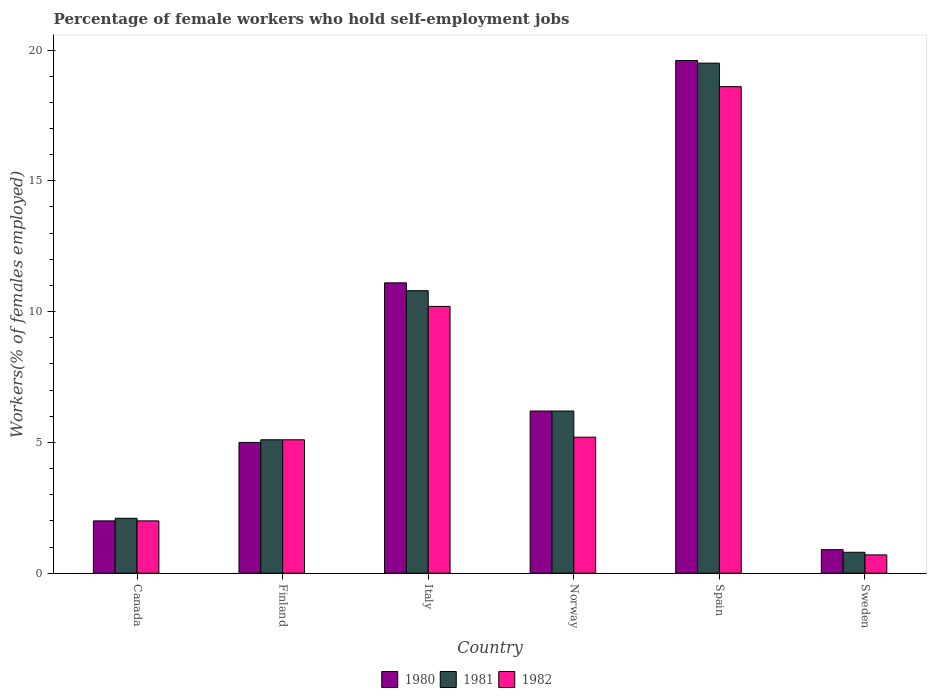How many groups of bars are there?
Your response must be concise. 6. Are the number of bars per tick equal to the number of legend labels?
Your answer should be very brief. Yes. Are the number of bars on each tick of the X-axis equal?
Your response must be concise. Yes. How many bars are there on the 6th tick from the right?
Your answer should be compact. 3. In how many cases, is the number of bars for a given country not equal to the number of legend labels?
Offer a very short reply. 0. What is the percentage of self-employed female workers in 1982 in Finland?
Keep it short and to the point. 5.1. Across all countries, what is the maximum percentage of self-employed female workers in 1980?
Provide a short and direct response. 19.6. Across all countries, what is the minimum percentage of self-employed female workers in 1981?
Provide a short and direct response. 0.8. In which country was the percentage of self-employed female workers in 1982 maximum?
Your answer should be very brief. Spain. In which country was the percentage of self-employed female workers in 1981 minimum?
Provide a short and direct response. Sweden. What is the total percentage of self-employed female workers in 1980 in the graph?
Offer a very short reply. 44.8. What is the difference between the percentage of self-employed female workers in 1981 in Finland and that in Spain?
Your response must be concise. -14.4. What is the difference between the percentage of self-employed female workers in 1980 in Canada and the percentage of self-employed female workers in 1981 in Spain?
Offer a very short reply. -17.5. What is the average percentage of self-employed female workers in 1982 per country?
Give a very brief answer. 6.97. What is the difference between the percentage of self-employed female workers of/in 1981 and percentage of self-employed female workers of/in 1980 in Italy?
Keep it short and to the point. -0.3. What is the ratio of the percentage of self-employed female workers in 1980 in Spain to that in Sweden?
Your answer should be very brief. 21.78. What is the difference between the highest and the second highest percentage of self-employed female workers in 1980?
Keep it short and to the point. -8.5. What is the difference between the highest and the lowest percentage of self-employed female workers in 1980?
Your response must be concise. 18.7. In how many countries, is the percentage of self-employed female workers in 1980 greater than the average percentage of self-employed female workers in 1980 taken over all countries?
Give a very brief answer. 2. Is the sum of the percentage of self-employed female workers in 1980 in Italy and Sweden greater than the maximum percentage of self-employed female workers in 1981 across all countries?
Provide a succinct answer. No. Is it the case that in every country, the sum of the percentage of self-employed female workers in 1981 and percentage of self-employed female workers in 1982 is greater than the percentage of self-employed female workers in 1980?
Ensure brevity in your answer.  Yes. How many bars are there?
Your response must be concise. 18. Are all the bars in the graph horizontal?
Your answer should be very brief. No. How many countries are there in the graph?
Provide a short and direct response. 6. Does the graph contain any zero values?
Your response must be concise. No. How many legend labels are there?
Provide a short and direct response. 3. How are the legend labels stacked?
Make the answer very short. Horizontal. What is the title of the graph?
Make the answer very short. Percentage of female workers who hold self-employment jobs. What is the label or title of the X-axis?
Provide a short and direct response. Country. What is the label or title of the Y-axis?
Provide a short and direct response. Workers(% of females employed). What is the Workers(% of females employed) in 1980 in Canada?
Offer a very short reply. 2. What is the Workers(% of females employed) of 1981 in Canada?
Ensure brevity in your answer.  2.1. What is the Workers(% of females employed) in 1982 in Canada?
Make the answer very short. 2. What is the Workers(% of females employed) of 1980 in Finland?
Your response must be concise. 5. What is the Workers(% of females employed) in 1981 in Finland?
Make the answer very short. 5.1. What is the Workers(% of females employed) in 1982 in Finland?
Offer a very short reply. 5.1. What is the Workers(% of females employed) of 1980 in Italy?
Give a very brief answer. 11.1. What is the Workers(% of females employed) of 1981 in Italy?
Provide a succinct answer. 10.8. What is the Workers(% of females employed) in 1982 in Italy?
Your response must be concise. 10.2. What is the Workers(% of females employed) of 1980 in Norway?
Make the answer very short. 6.2. What is the Workers(% of females employed) in 1981 in Norway?
Your answer should be compact. 6.2. What is the Workers(% of females employed) of 1982 in Norway?
Provide a short and direct response. 5.2. What is the Workers(% of females employed) in 1980 in Spain?
Offer a very short reply. 19.6. What is the Workers(% of females employed) in 1981 in Spain?
Ensure brevity in your answer.  19.5. What is the Workers(% of females employed) in 1982 in Spain?
Provide a short and direct response. 18.6. What is the Workers(% of females employed) of 1980 in Sweden?
Offer a very short reply. 0.9. What is the Workers(% of females employed) in 1981 in Sweden?
Give a very brief answer. 0.8. What is the Workers(% of females employed) of 1982 in Sweden?
Provide a short and direct response. 0.7. Across all countries, what is the maximum Workers(% of females employed) in 1980?
Your answer should be compact. 19.6. Across all countries, what is the maximum Workers(% of females employed) of 1981?
Your answer should be compact. 19.5. Across all countries, what is the maximum Workers(% of females employed) of 1982?
Offer a very short reply. 18.6. Across all countries, what is the minimum Workers(% of females employed) of 1980?
Your answer should be compact. 0.9. Across all countries, what is the minimum Workers(% of females employed) of 1981?
Your response must be concise. 0.8. Across all countries, what is the minimum Workers(% of females employed) in 1982?
Make the answer very short. 0.7. What is the total Workers(% of females employed) of 1980 in the graph?
Make the answer very short. 44.8. What is the total Workers(% of females employed) of 1981 in the graph?
Give a very brief answer. 44.5. What is the total Workers(% of females employed) in 1982 in the graph?
Ensure brevity in your answer.  41.8. What is the difference between the Workers(% of females employed) of 1980 in Canada and that in Finland?
Provide a short and direct response. -3. What is the difference between the Workers(% of females employed) in 1980 in Canada and that in Italy?
Your answer should be very brief. -9.1. What is the difference between the Workers(% of females employed) of 1981 in Canada and that in Italy?
Offer a very short reply. -8.7. What is the difference between the Workers(% of females employed) of 1980 in Canada and that in Norway?
Offer a very short reply. -4.2. What is the difference between the Workers(% of females employed) in 1982 in Canada and that in Norway?
Offer a very short reply. -3.2. What is the difference between the Workers(% of females employed) in 1980 in Canada and that in Spain?
Offer a very short reply. -17.6. What is the difference between the Workers(% of females employed) of 1981 in Canada and that in Spain?
Your response must be concise. -17.4. What is the difference between the Workers(% of females employed) in 1982 in Canada and that in Spain?
Your response must be concise. -16.6. What is the difference between the Workers(% of females employed) of 1980 in Canada and that in Sweden?
Make the answer very short. 1.1. What is the difference between the Workers(% of females employed) of 1981 in Canada and that in Sweden?
Provide a short and direct response. 1.3. What is the difference between the Workers(% of females employed) in 1982 in Canada and that in Sweden?
Your answer should be very brief. 1.3. What is the difference between the Workers(% of females employed) in 1980 in Finland and that in Italy?
Keep it short and to the point. -6.1. What is the difference between the Workers(% of females employed) of 1981 in Finland and that in Italy?
Offer a terse response. -5.7. What is the difference between the Workers(% of females employed) in 1982 in Finland and that in Italy?
Keep it short and to the point. -5.1. What is the difference between the Workers(% of females employed) in 1980 in Finland and that in Spain?
Keep it short and to the point. -14.6. What is the difference between the Workers(% of females employed) in 1981 in Finland and that in Spain?
Give a very brief answer. -14.4. What is the difference between the Workers(% of females employed) in 1982 in Finland and that in Spain?
Keep it short and to the point. -13.5. What is the difference between the Workers(% of females employed) in 1980 in Finland and that in Sweden?
Offer a very short reply. 4.1. What is the difference between the Workers(% of females employed) of 1981 in Finland and that in Sweden?
Your answer should be compact. 4.3. What is the difference between the Workers(% of females employed) in 1980 in Italy and that in Spain?
Provide a short and direct response. -8.5. What is the difference between the Workers(% of females employed) in 1981 in Italy and that in Spain?
Offer a terse response. -8.7. What is the difference between the Workers(% of females employed) of 1982 in Italy and that in Spain?
Ensure brevity in your answer.  -8.4. What is the difference between the Workers(% of females employed) of 1980 in Italy and that in Sweden?
Offer a terse response. 10.2. What is the difference between the Workers(% of females employed) of 1981 in Italy and that in Sweden?
Keep it short and to the point. 10. What is the difference between the Workers(% of females employed) in 1982 in Italy and that in Sweden?
Provide a short and direct response. 9.5. What is the difference between the Workers(% of females employed) of 1980 in Norway and that in Spain?
Ensure brevity in your answer.  -13.4. What is the difference between the Workers(% of females employed) of 1981 in Norway and that in Spain?
Offer a terse response. -13.3. What is the difference between the Workers(% of females employed) in 1980 in Canada and the Workers(% of females employed) in 1981 in Finland?
Ensure brevity in your answer.  -3.1. What is the difference between the Workers(% of females employed) of 1980 in Canada and the Workers(% of females employed) of 1982 in Finland?
Your answer should be very brief. -3.1. What is the difference between the Workers(% of females employed) of 1980 in Canada and the Workers(% of females employed) of 1982 in Norway?
Your answer should be very brief. -3.2. What is the difference between the Workers(% of females employed) of 1980 in Canada and the Workers(% of females employed) of 1981 in Spain?
Offer a terse response. -17.5. What is the difference between the Workers(% of females employed) in 1980 in Canada and the Workers(% of females employed) in 1982 in Spain?
Make the answer very short. -16.6. What is the difference between the Workers(% of females employed) in 1981 in Canada and the Workers(% of females employed) in 1982 in Spain?
Your response must be concise. -16.5. What is the difference between the Workers(% of females employed) of 1980 in Canada and the Workers(% of females employed) of 1981 in Sweden?
Make the answer very short. 1.2. What is the difference between the Workers(% of females employed) in 1980 in Canada and the Workers(% of females employed) in 1982 in Sweden?
Ensure brevity in your answer.  1.3. What is the difference between the Workers(% of females employed) of 1981 in Finland and the Workers(% of females employed) of 1982 in Italy?
Keep it short and to the point. -5.1. What is the difference between the Workers(% of females employed) of 1980 in Finland and the Workers(% of females employed) of 1982 in Norway?
Offer a terse response. -0.2. What is the difference between the Workers(% of females employed) of 1981 in Finland and the Workers(% of females employed) of 1982 in Spain?
Make the answer very short. -13.5. What is the difference between the Workers(% of females employed) of 1980 in Italy and the Workers(% of females employed) of 1981 in Spain?
Give a very brief answer. -8.4. What is the difference between the Workers(% of females employed) of 1980 in Italy and the Workers(% of females employed) of 1982 in Spain?
Give a very brief answer. -7.5. What is the difference between the Workers(% of females employed) of 1980 in Italy and the Workers(% of females employed) of 1981 in Sweden?
Ensure brevity in your answer.  10.3. What is the difference between the Workers(% of females employed) in 1980 in Norway and the Workers(% of females employed) in 1981 in Spain?
Offer a terse response. -13.3. What is the difference between the Workers(% of females employed) of 1981 in Norway and the Workers(% of females employed) of 1982 in Spain?
Give a very brief answer. -12.4. What is the difference between the Workers(% of females employed) of 1981 in Norway and the Workers(% of females employed) of 1982 in Sweden?
Offer a terse response. 5.5. What is the difference between the Workers(% of females employed) of 1981 in Spain and the Workers(% of females employed) of 1982 in Sweden?
Provide a succinct answer. 18.8. What is the average Workers(% of females employed) of 1980 per country?
Provide a succinct answer. 7.47. What is the average Workers(% of females employed) in 1981 per country?
Provide a short and direct response. 7.42. What is the average Workers(% of females employed) in 1982 per country?
Make the answer very short. 6.97. What is the difference between the Workers(% of females employed) of 1980 and Workers(% of females employed) of 1981 in Canada?
Ensure brevity in your answer.  -0.1. What is the difference between the Workers(% of females employed) of 1980 and Workers(% of females employed) of 1982 in Italy?
Give a very brief answer. 0.9. What is the difference between the Workers(% of females employed) in 1980 and Workers(% of females employed) in 1981 in Norway?
Provide a succinct answer. 0. What is the difference between the Workers(% of females employed) of 1981 and Workers(% of females employed) of 1982 in Norway?
Your answer should be very brief. 1. What is the difference between the Workers(% of females employed) of 1980 and Workers(% of females employed) of 1981 in Spain?
Provide a succinct answer. 0.1. What is the difference between the Workers(% of females employed) of 1980 and Workers(% of females employed) of 1981 in Sweden?
Provide a short and direct response. 0.1. What is the ratio of the Workers(% of females employed) in 1980 in Canada to that in Finland?
Make the answer very short. 0.4. What is the ratio of the Workers(% of females employed) of 1981 in Canada to that in Finland?
Your answer should be compact. 0.41. What is the ratio of the Workers(% of females employed) in 1982 in Canada to that in Finland?
Provide a short and direct response. 0.39. What is the ratio of the Workers(% of females employed) of 1980 in Canada to that in Italy?
Your response must be concise. 0.18. What is the ratio of the Workers(% of females employed) in 1981 in Canada to that in Italy?
Your answer should be compact. 0.19. What is the ratio of the Workers(% of females employed) of 1982 in Canada to that in Italy?
Your response must be concise. 0.2. What is the ratio of the Workers(% of females employed) in 1980 in Canada to that in Norway?
Your answer should be very brief. 0.32. What is the ratio of the Workers(% of females employed) of 1981 in Canada to that in Norway?
Your answer should be very brief. 0.34. What is the ratio of the Workers(% of females employed) in 1982 in Canada to that in Norway?
Give a very brief answer. 0.38. What is the ratio of the Workers(% of females employed) in 1980 in Canada to that in Spain?
Your answer should be compact. 0.1. What is the ratio of the Workers(% of females employed) of 1981 in Canada to that in Spain?
Provide a short and direct response. 0.11. What is the ratio of the Workers(% of females employed) in 1982 in Canada to that in Spain?
Offer a terse response. 0.11. What is the ratio of the Workers(% of females employed) in 1980 in Canada to that in Sweden?
Offer a very short reply. 2.22. What is the ratio of the Workers(% of females employed) of 1981 in Canada to that in Sweden?
Offer a terse response. 2.62. What is the ratio of the Workers(% of females employed) in 1982 in Canada to that in Sweden?
Provide a short and direct response. 2.86. What is the ratio of the Workers(% of females employed) in 1980 in Finland to that in Italy?
Offer a terse response. 0.45. What is the ratio of the Workers(% of females employed) in 1981 in Finland to that in Italy?
Your answer should be compact. 0.47. What is the ratio of the Workers(% of females employed) in 1980 in Finland to that in Norway?
Give a very brief answer. 0.81. What is the ratio of the Workers(% of females employed) of 1981 in Finland to that in Norway?
Offer a terse response. 0.82. What is the ratio of the Workers(% of females employed) of 1982 in Finland to that in Norway?
Provide a short and direct response. 0.98. What is the ratio of the Workers(% of females employed) in 1980 in Finland to that in Spain?
Make the answer very short. 0.26. What is the ratio of the Workers(% of females employed) in 1981 in Finland to that in Spain?
Keep it short and to the point. 0.26. What is the ratio of the Workers(% of females employed) in 1982 in Finland to that in Spain?
Your answer should be compact. 0.27. What is the ratio of the Workers(% of females employed) of 1980 in Finland to that in Sweden?
Make the answer very short. 5.56. What is the ratio of the Workers(% of females employed) in 1981 in Finland to that in Sweden?
Your response must be concise. 6.38. What is the ratio of the Workers(% of females employed) of 1982 in Finland to that in Sweden?
Make the answer very short. 7.29. What is the ratio of the Workers(% of females employed) of 1980 in Italy to that in Norway?
Your answer should be very brief. 1.79. What is the ratio of the Workers(% of females employed) of 1981 in Italy to that in Norway?
Keep it short and to the point. 1.74. What is the ratio of the Workers(% of females employed) of 1982 in Italy to that in Norway?
Offer a terse response. 1.96. What is the ratio of the Workers(% of females employed) of 1980 in Italy to that in Spain?
Provide a succinct answer. 0.57. What is the ratio of the Workers(% of females employed) of 1981 in Italy to that in Spain?
Provide a short and direct response. 0.55. What is the ratio of the Workers(% of females employed) in 1982 in Italy to that in Spain?
Offer a terse response. 0.55. What is the ratio of the Workers(% of females employed) of 1980 in Italy to that in Sweden?
Offer a very short reply. 12.33. What is the ratio of the Workers(% of females employed) of 1981 in Italy to that in Sweden?
Provide a short and direct response. 13.5. What is the ratio of the Workers(% of females employed) in 1982 in Italy to that in Sweden?
Your answer should be very brief. 14.57. What is the ratio of the Workers(% of females employed) of 1980 in Norway to that in Spain?
Offer a very short reply. 0.32. What is the ratio of the Workers(% of females employed) of 1981 in Norway to that in Spain?
Offer a terse response. 0.32. What is the ratio of the Workers(% of females employed) of 1982 in Norway to that in Spain?
Make the answer very short. 0.28. What is the ratio of the Workers(% of females employed) of 1980 in Norway to that in Sweden?
Offer a very short reply. 6.89. What is the ratio of the Workers(% of females employed) of 1981 in Norway to that in Sweden?
Provide a succinct answer. 7.75. What is the ratio of the Workers(% of females employed) of 1982 in Norway to that in Sweden?
Keep it short and to the point. 7.43. What is the ratio of the Workers(% of females employed) of 1980 in Spain to that in Sweden?
Offer a terse response. 21.78. What is the ratio of the Workers(% of females employed) of 1981 in Spain to that in Sweden?
Ensure brevity in your answer.  24.38. What is the ratio of the Workers(% of females employed) in 1982 in Spain to that in Sweden?
Ensure brevity in your answer.  26.57. What is the difference between the highest and the second highest Workers(% of females employed) in 1980?
Make the answer very short. 8.5. 